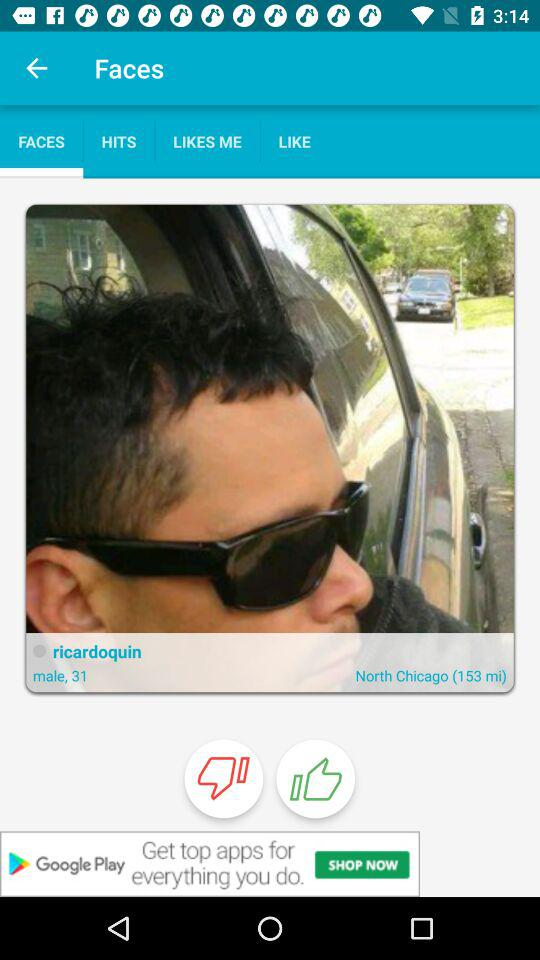What is the location of "ricardoquin"? The location of "ricardoquin" is North Chicago. 